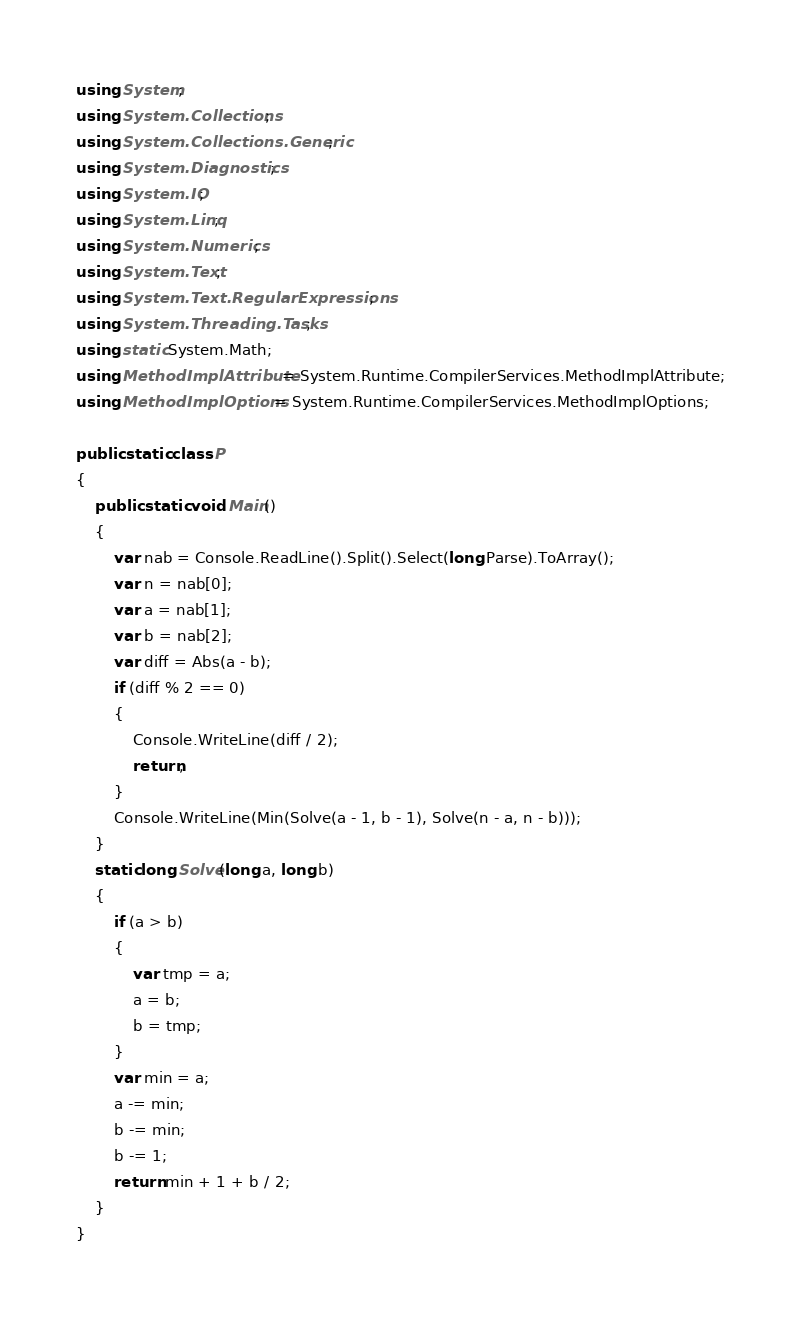<code> <loc_0><loc_0><loc_500><loc_500><_C#_>using System;
using System.Collections;
using System.Collections.Generic;
using System.Diagnostics;
using System.IO;
using System.Linq;
using System.Numerics;
using System.Text;
using System.Text.RegularExpressions;
using System.Threading.Tasks;
using static System.Math;
using MethodImplAttribute = System.Runtime.CompilerServices.MethodImplAttribute;
using MethodImplOptions = System.Runtime.CompilerServices.MethodImplOptions;

public static class P
{
    public static void Main()
    {
        var nab = Console.ReadLine().Split().Select(long.Parse).ToArray();
        var n = nab[0];
        var a = nab[1];
        var b = nab[2];
        var diff = Abs(a - b);
        if (diff % 2 == 0)
        {
            Console.WriteLine(diff / 2);
            return;
        }
        Console.WriteLine(Min(Solve(a - 1, b - 1), Solve(n - a, n - b)));
    }
    static long Solve(long a, long b)
    {
        if (a > b)
        {
            var tmp = a;
            a = b;
            b = tmp;
        }
        var min = a;
        a -= min;
        b -= min;
        b -= 1;
        return min + 1 + b / 2;
    }
}
</code> 